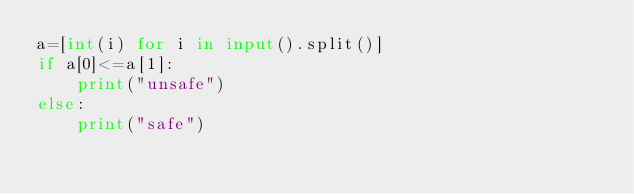<code> <loc_0><loc_0><loc_500><loc_500><_Python_>a=[int(i) for i in input().split()]
if a[0]<=a[1]:
    print("unsafe")
else:
    print("safe")</code> 